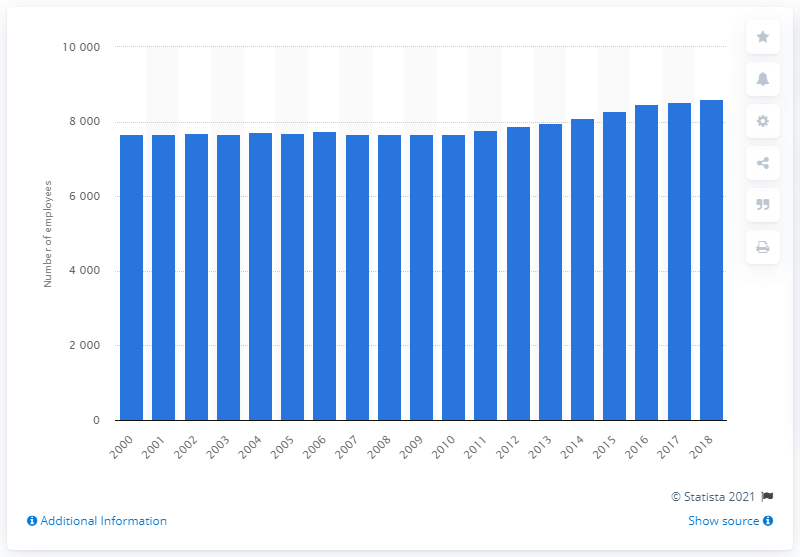Give some essential details in this illustration. In 2018, there were 8,614 dentists employed in Belgium. 